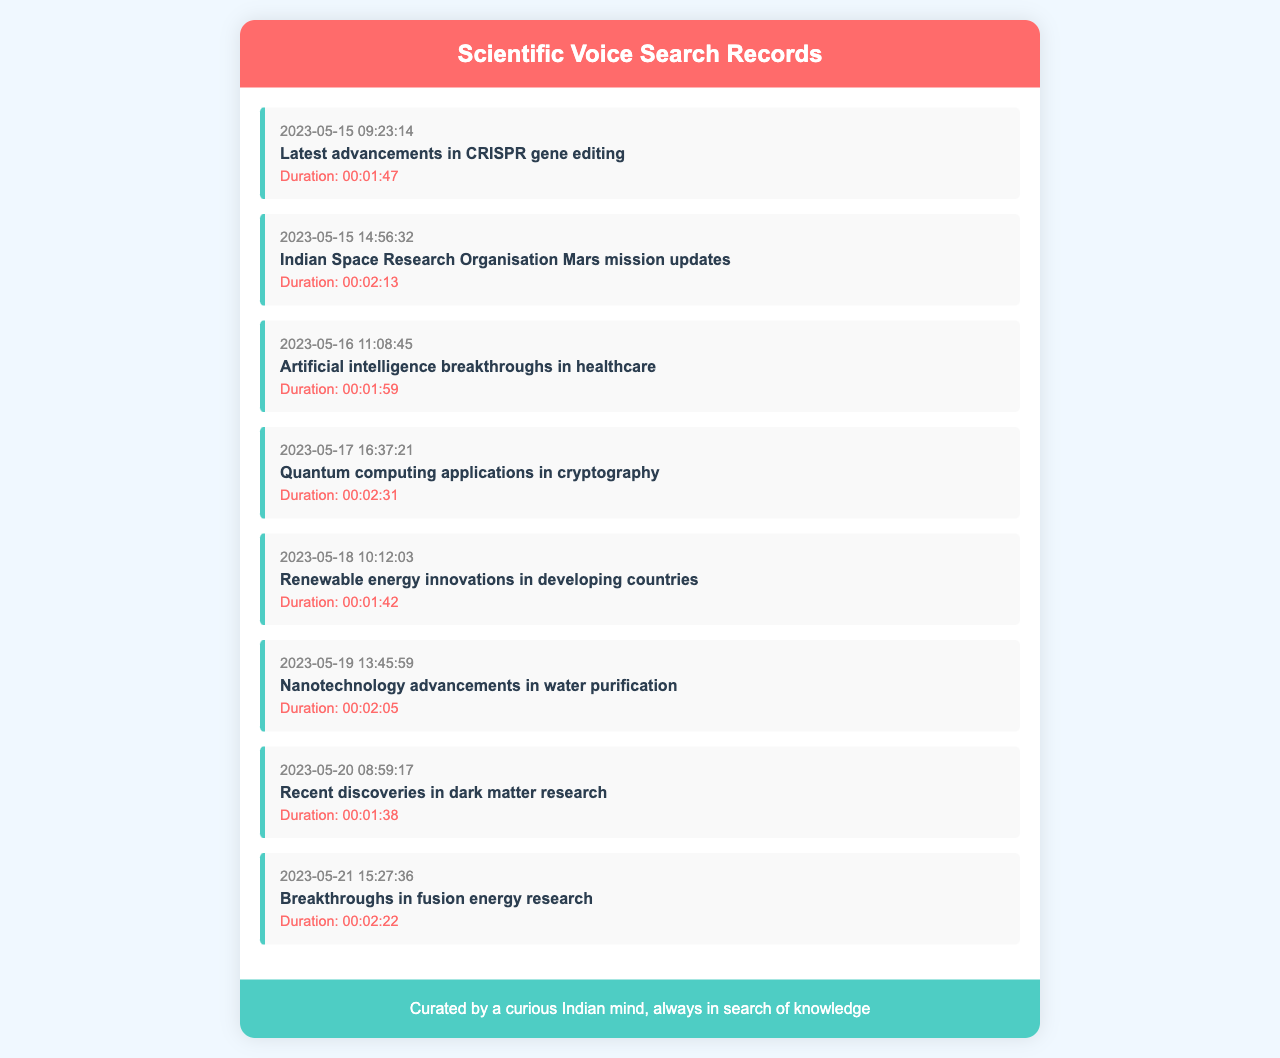What was the first query recorded? The first query recorded is the one that appears at the top of the list under the timestamp.
Answer: Latest advancements in CRISPR gene editing What is the duration of the query related to dark matter? The duration for the query regarding dark matter research is listed alongside it in the record.
Answer: Duration: 00:01:38 How many records are listed in total? The total number of records is determined by counting the individual entries in the document.
Answer: 8 What query was made on May 19? This date has a specific query associated with it which can be found in the records.
Answer: Nanotechnology advancements in water purification Which topic appears to be related to energy research? By reviewing the queries, we can find topics that pertain to energy and highlight them.
Answer: Breakthroughs in fusion energy research What was the timestamp for the query about quantum computing? This timestamp specifically indicates when the quantum computing query was recorded in the document.
Answer: 2023-05-17 16:37:21 How long was the duration for the query regarding AI and healthcare? The duration for this query can be found within the individual record entry.
Answer: Duration: 00:01:59 What is the main focus of the query made on May 18? The focus can be found by looking closely at the text of the respective query.
Answer: Renewable energy innovations in developing countries 